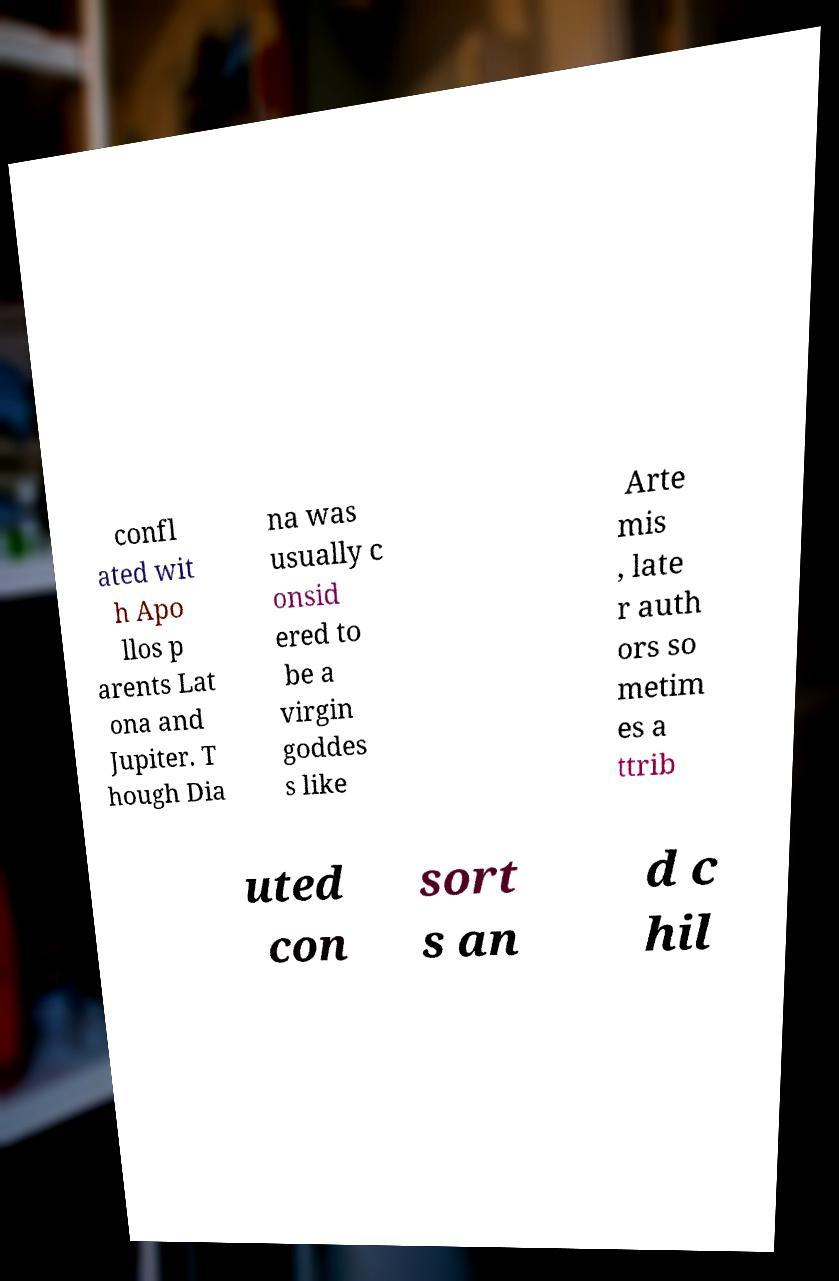What messages or text are displayed in this image? I need them in a readable, typed format. confl ated wit h Apo llos p arents Lat ona and Jupiter. T hough Dia na was usually c onsid ered to be a virgin goddes s like Arte mis , late r auth ors so metim es a ttrib uted con sort s an d c hil 